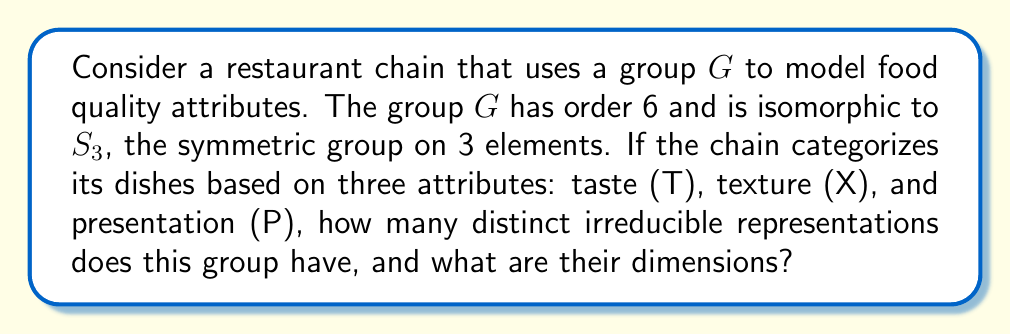Help me with this question. To solve this problem, we'll follow these steps:

1) First, recall that $S_3$ is isomorphic to the dihedral group $D_3$, which has 6 elements.

2) For any finite group, the number of irreducible representations is equal to the number of conjugacy classes. Let's find the conjugacy classes of $S_3$:

   - Identity: {e}
   - Transpositions: {(12), (13), (23)}
   - 3-cycles: {(123), (132)}

   There are 3 conjugacy classes.

3) The sum of the squares of the dimensions of irreducible representations must equal the order of the group. Let's call the dimensions $d_1$, $d_2$, and $d_3$. We have:

   $$d_1^2 + d_2^2 + d_3^2 = 6$$

4) We know that every group has a trivial representation of dimension 1. So $d_1 = 1$.

5) $S_3$ is non-abelian, so it must have at least one representation of dimension greater than 1. The only possibility that satisfies the equation is:

   $$1^2 + 1^2 + 2^2 = 6$$

Therefore, $S_3$ (and consequently our group $G$) has:
- Two 1-dimensional irreducible representations
- One 2-dimensional irreducible representation

These representations correspond to how the restaurant chain can analyze its food quality attributes (taste, texture, presentation) in fundamentally distinct ways that cannot be broken down further.
Answer: 3 irreducible representations: two 1-dimensional and one 2-dimensional 